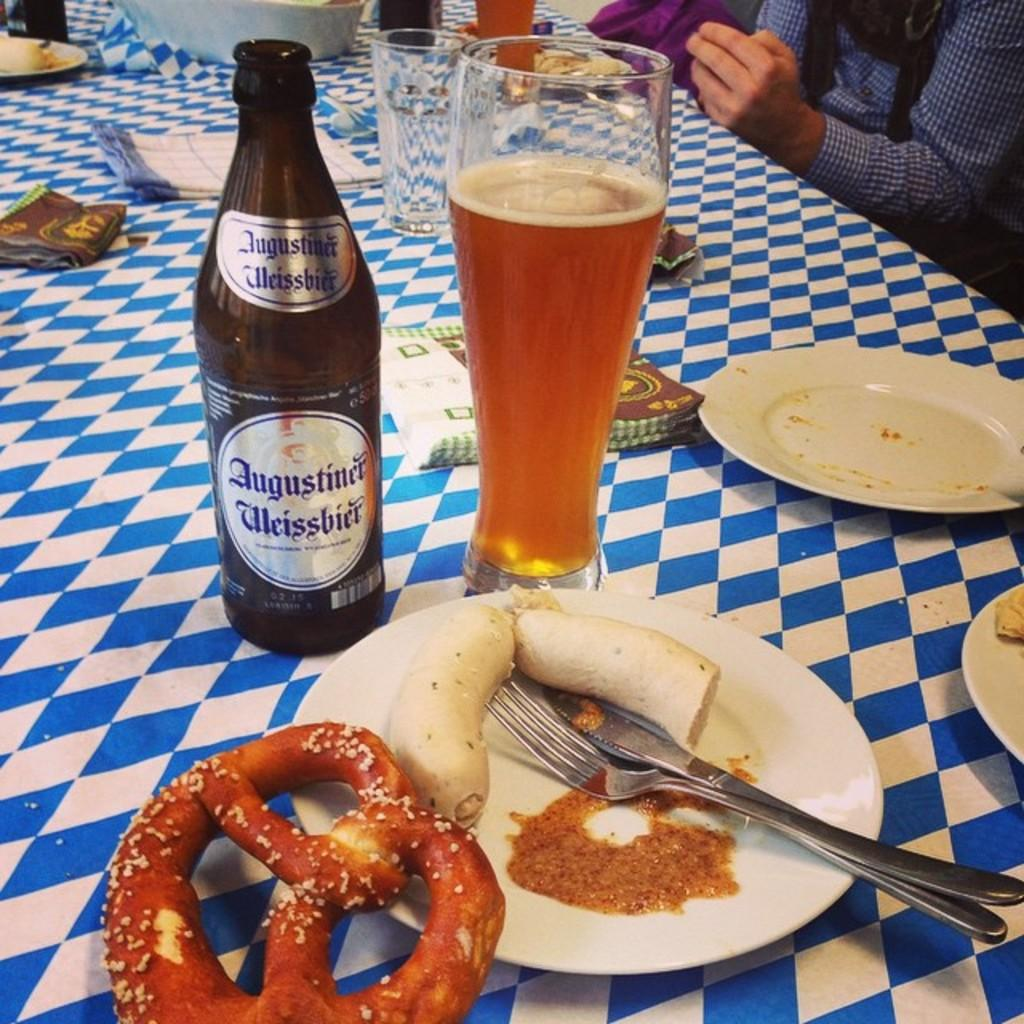What piece of furniture is present in the image? There is a table in the image. What items can be seen on the table? There are plates, spoons, a knife, napkins, a bottle, glasses, and bowls on the table. What is the purpose of the napkins on the table? The napkins on the table are likely for cleaning or wiping. What is the nature of the food on the table? The food on the table is not specified, but it is present. Can you describe the people in the background of the image? People are sitting in the background of the image, but their specific actions or characteristics are not mentioned. Where is the cannon located in the image? There is no cannon present in the image. What type of throne is visible in the image? There is no throne present in the image. 